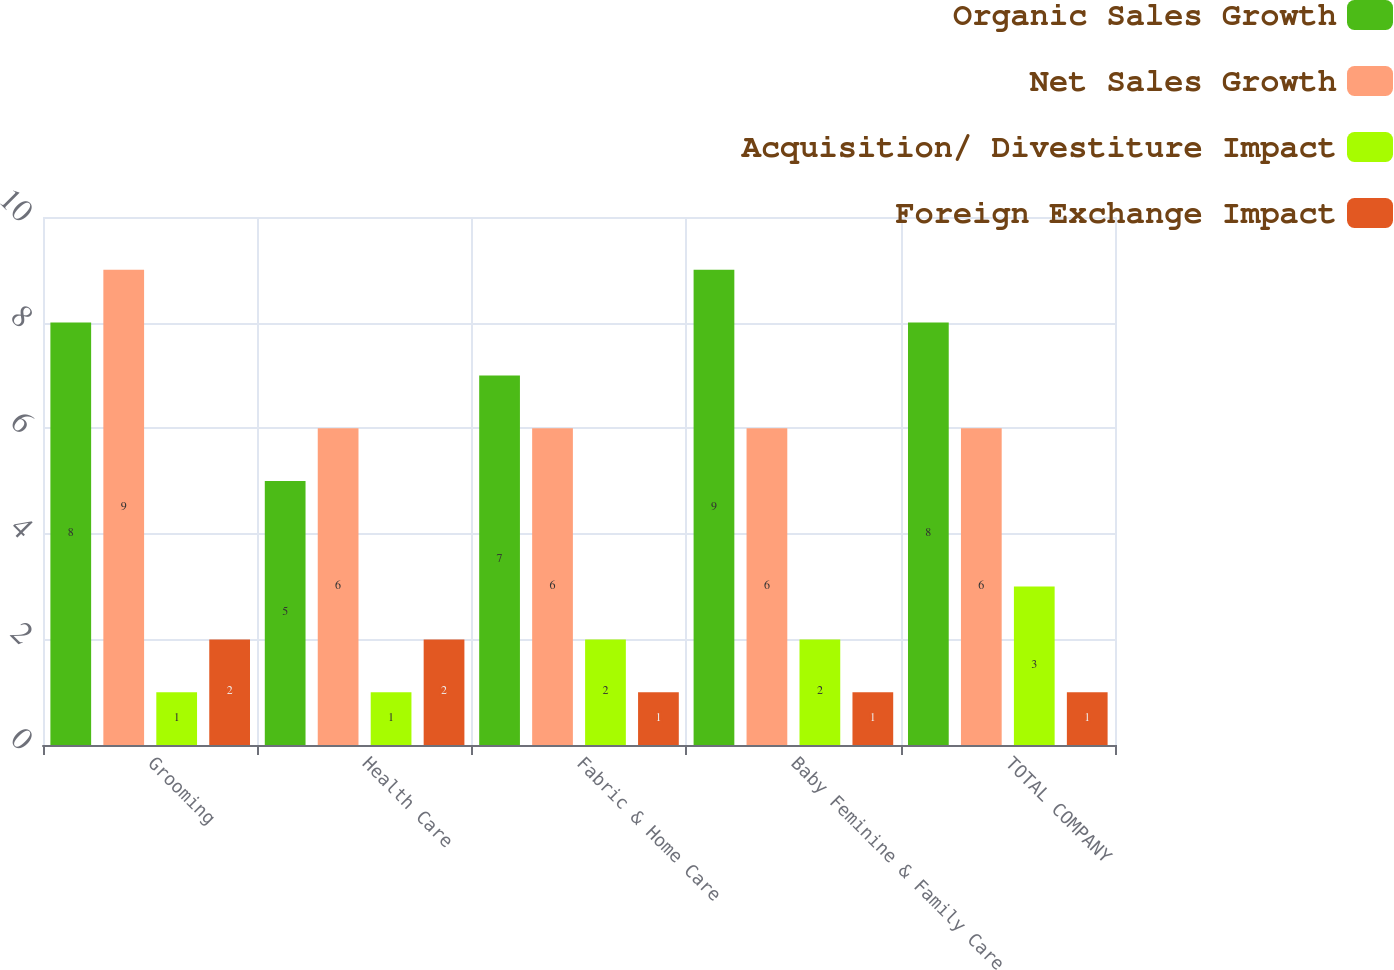Convert chart to OTSL. <chart><loc_0><loc_0><loc_500><loc_500><stacked_bar_chart><ecel><fcel>Grooming<fcel>Health Care<fcel>Fabric & Home Care<fcel>Baby Feminine & Family Care<fcel>TOTAL COMPANY<nl><fcel>Organic Sales Growth<fcel>8<fcel>5<fcel>7<fcel>9<fcel>8<nl><fcel>Net Sales Growth<fcel>9<fcel>6<fcel>6<fcel>6<fcel>6<nl><fcel>Acquisition/ Divestiture Impact<fcel>1<fcel>1<fcel>2<fcel>2<fcel>3<nl><fcel>Foreign Exchange Impact<fcel>2<fcel>2<fcel>1<fcel>1<fcel>1<nl></chart> 